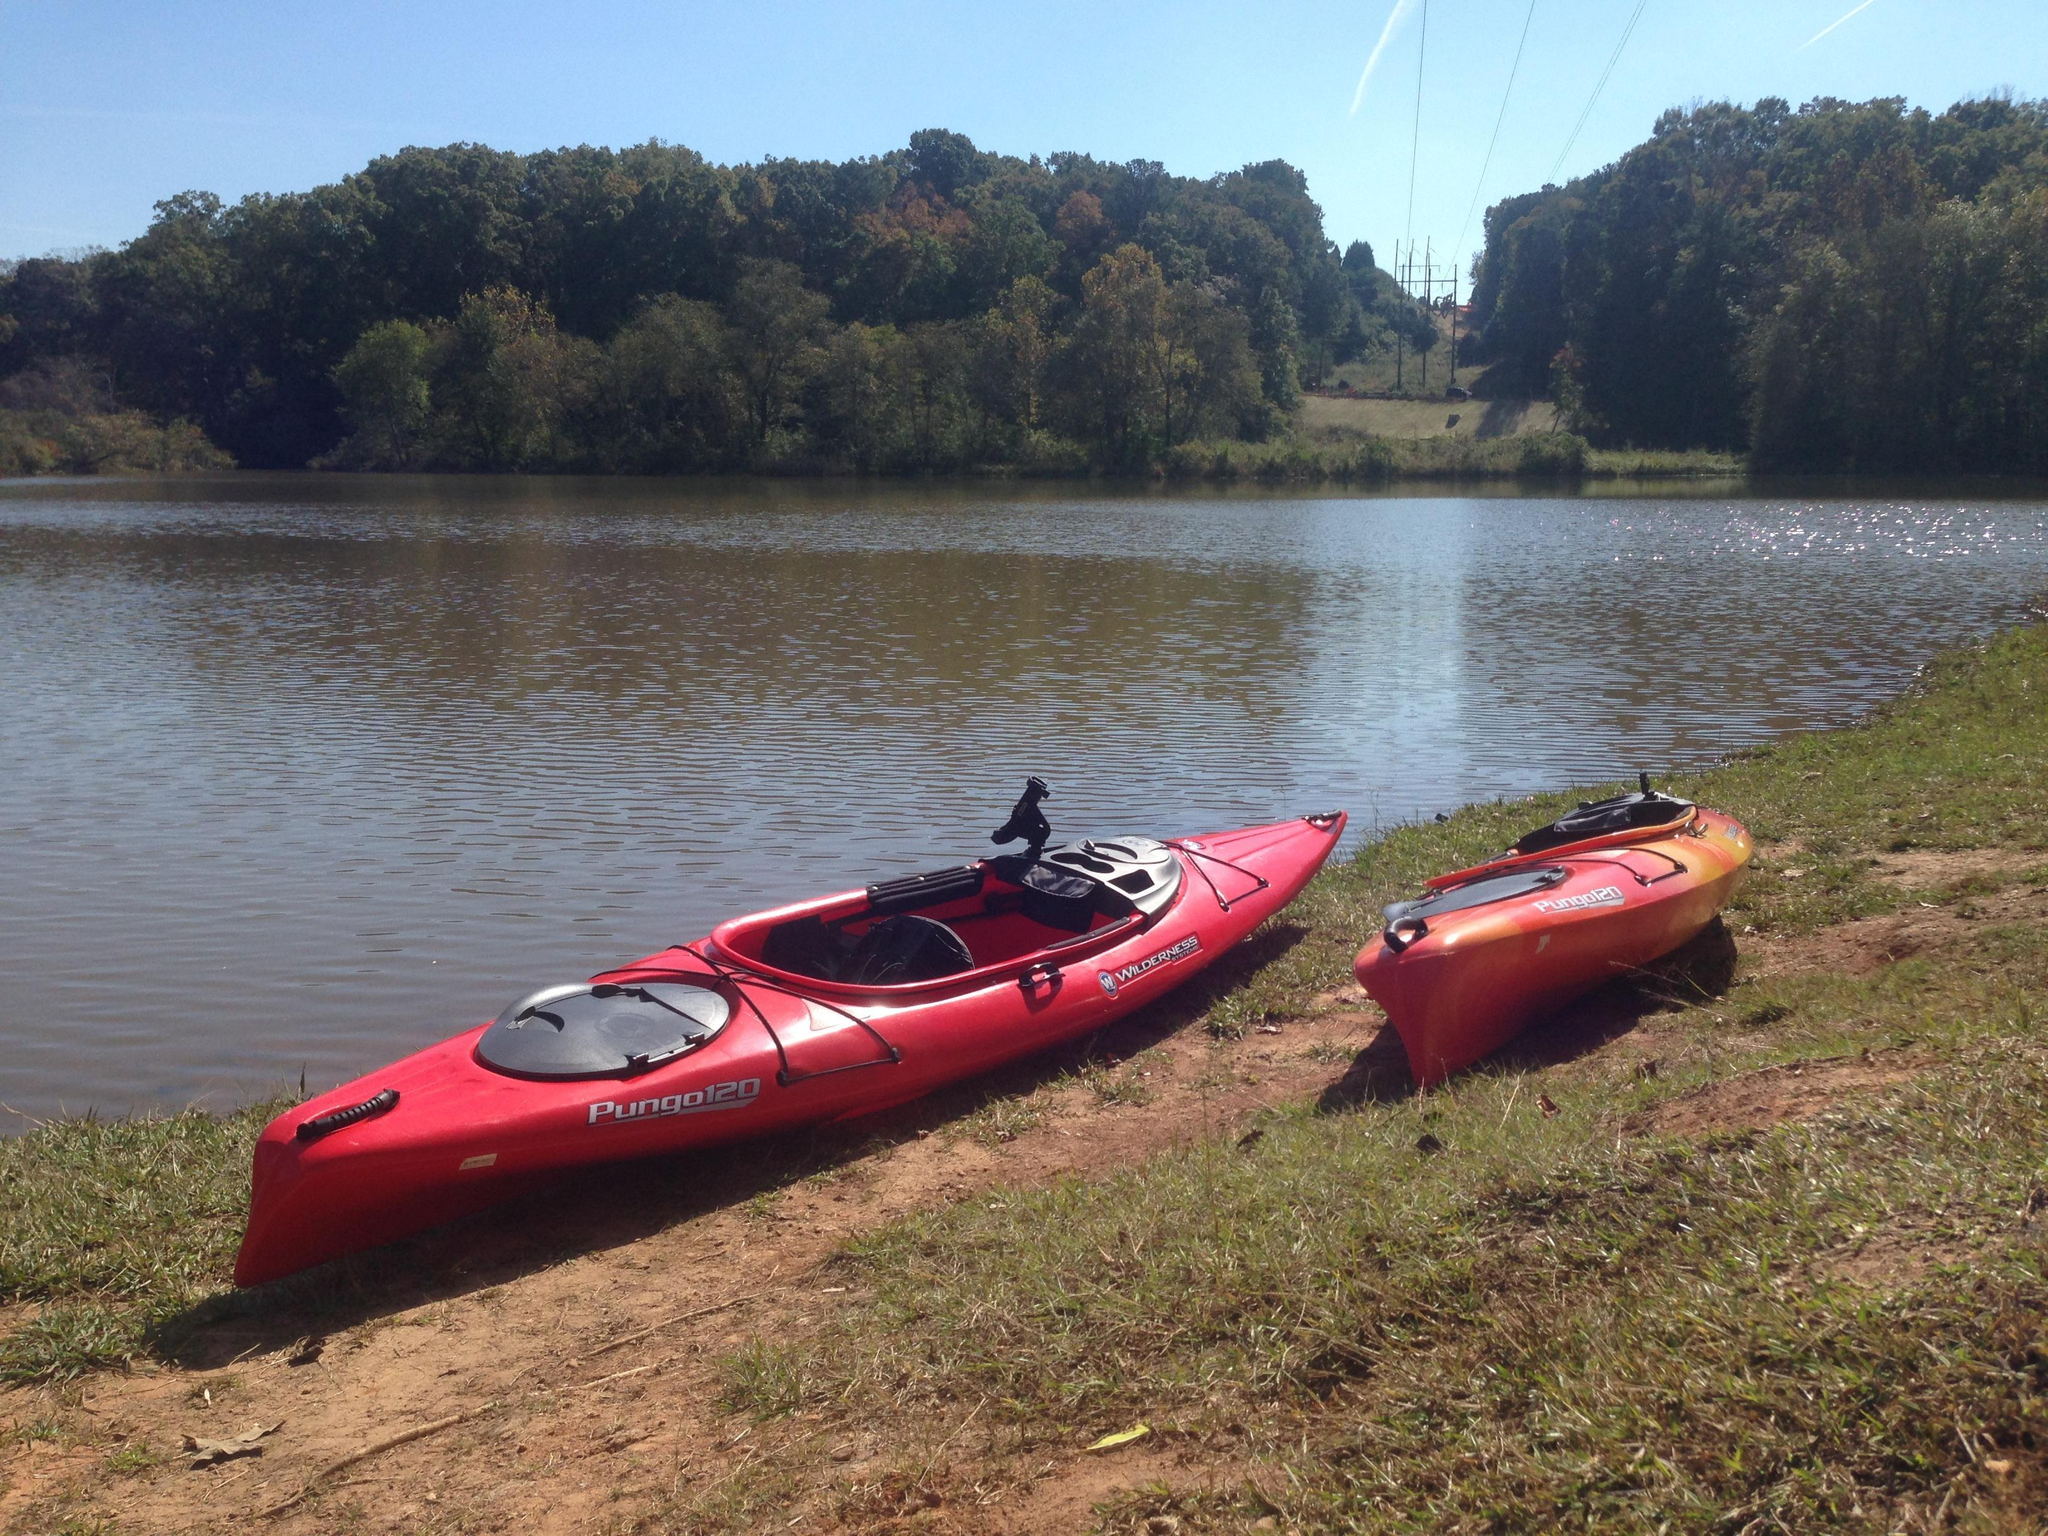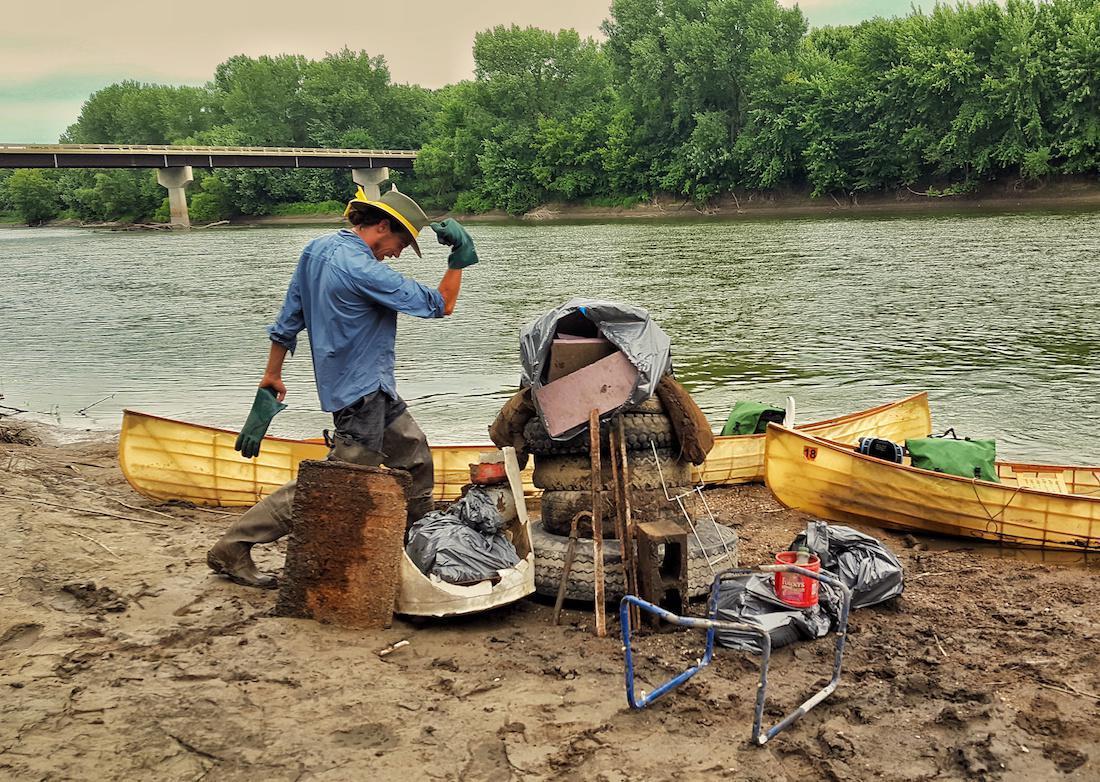The first image is the image on the left, the second image is the image on the right. Evaluate the accuracy of this statement regarding the images: "In at least one image there a at least two red boats on the shore.". Is it true? Answer yes or no. Yes. The first image is the image on the left, the second image is the image on the right. For the images displayed, is the sentence "The combined images include several red and yellow boats pulled up on shore." factually correct? Answer yes or no. Yes. 